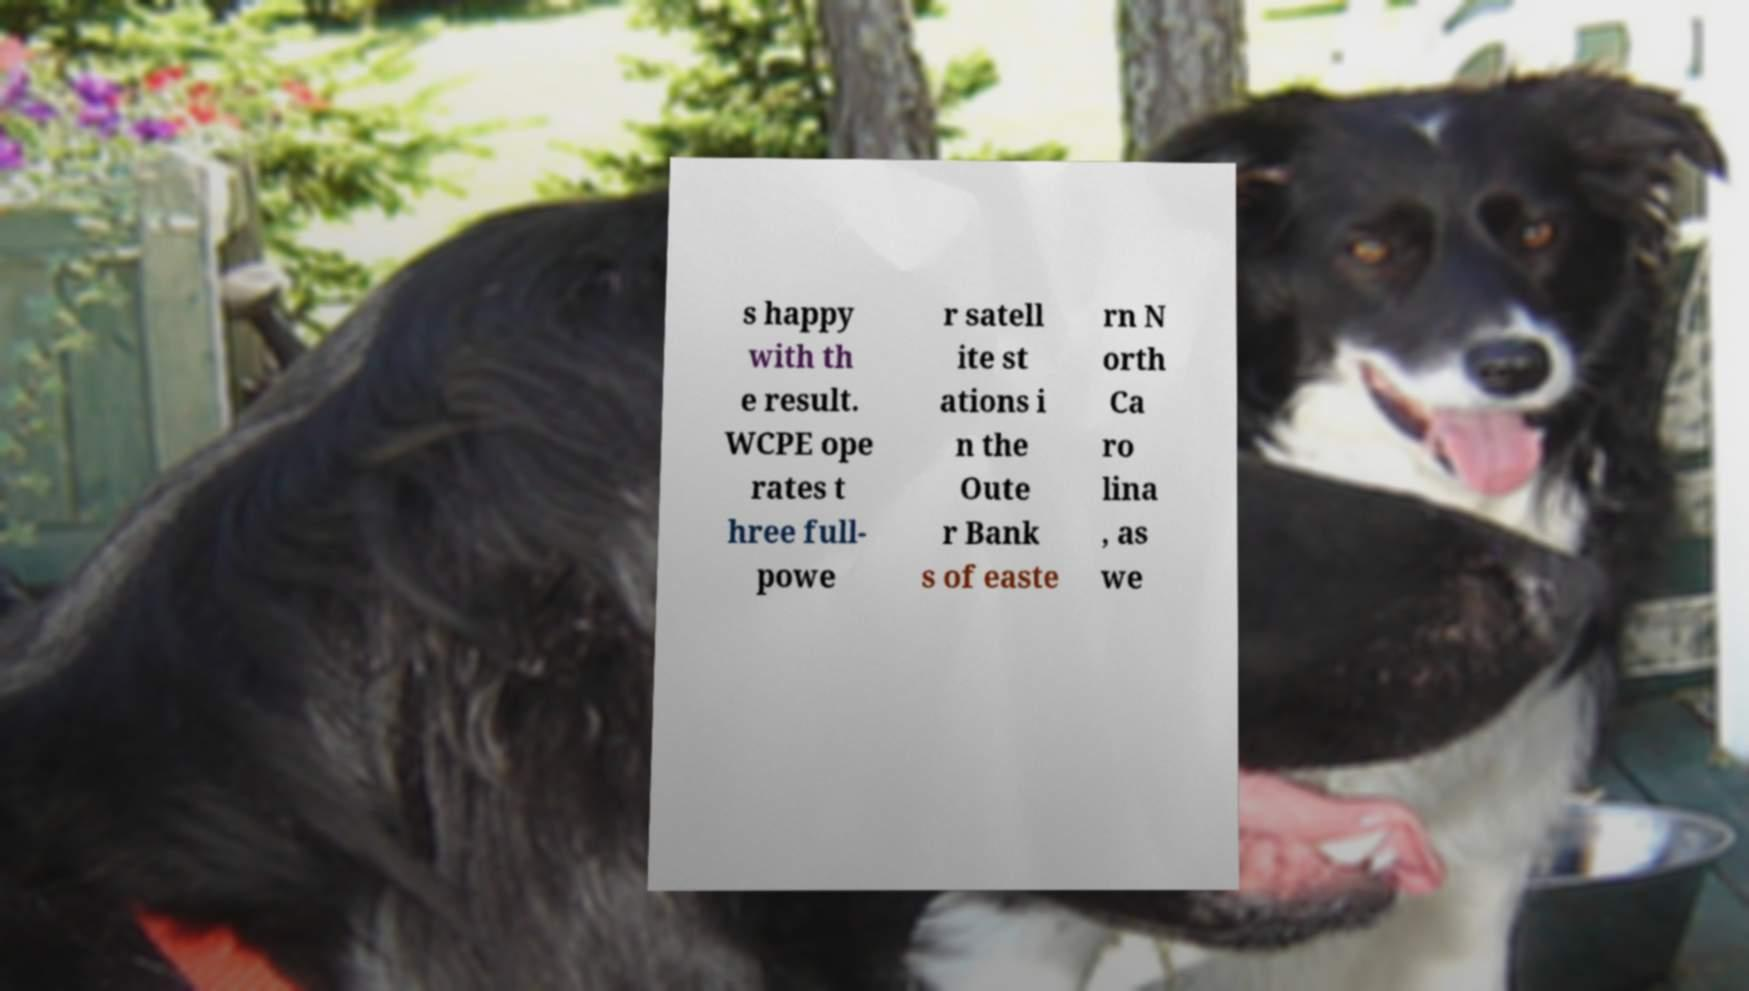What messages or text are displayed in this image? I need them in a readable, typed format. s happy with th e result. WCPE ope rates t hree full- powe r satell ite st ations i n the Oute r Bank s of easte rn N orth Ca ro lina , as we 